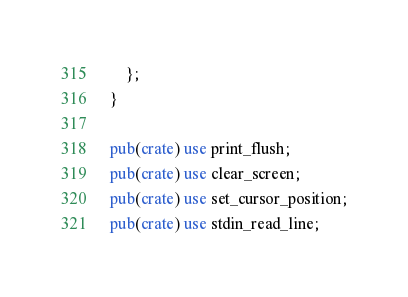<code> <loc_0><loc_0><loc_500><loc_500><_Rust_>    };
}

pub(crate) use print_flush;
pub(crate) use clear_screen;
pub(crate) use set_cursor_position;
pub(crate) use stdin_read_line;
</code> 